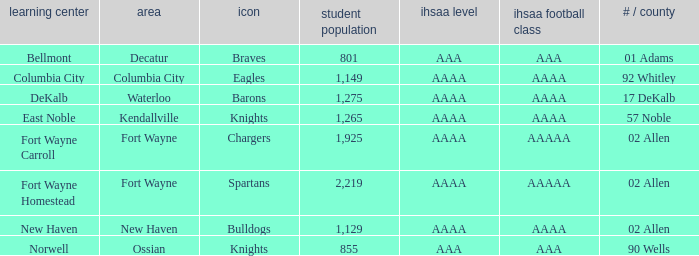What's the IHSAA Football Class in Decatur with an AAA IHSAA class? AAA. 